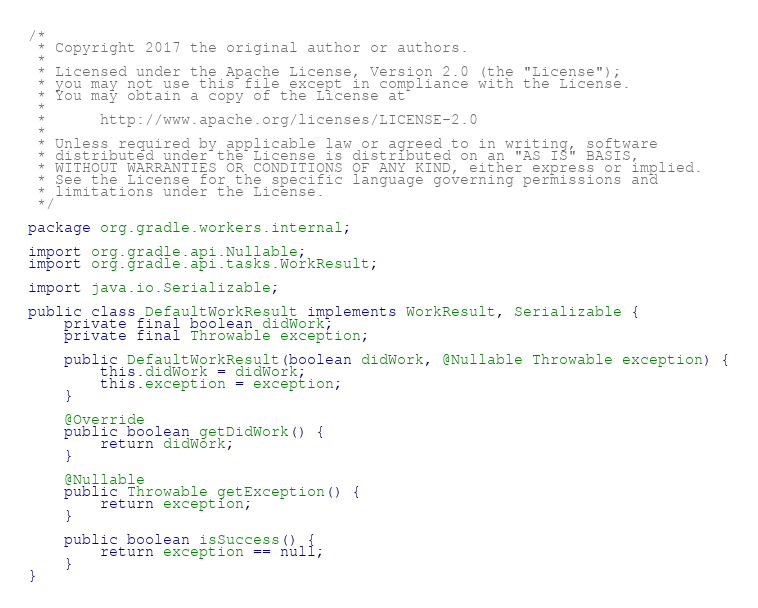<code> <loc_0><loc_0><loc_500><loc_500><_Java_>/*
 * Copyright 2017 the original author or authors.
 *
 * Licensed under the Apache License, Version 2.0 (the "License");
 * you may not use this file except in compliance with the License.
 * You may obtain a copy of the License at
 *
 *      http://www.apache.org/licenses/LICENSE-2.0
 *
 * Unless required by applicable law or agreed to in writing, software
 * distributed under the License is distributed on an "AS IS" BASIS,
 * WITHOUT WARRANTIES OR CONDITIONS OF ANY KIND, either express or implied.
 * See the License for the specific language governing permissions and
 * limitations under the License.
 */

package org.gradle.workers.internal;

import org.gradle.api.Nullable;
import org.gradle.api.tasks.WorkResult;

import java.io.Serializable;

public class DefaultWorkResult implements WorkResult, Serializable {
    private final boolean didWork;
    private final Throwable exception;

    public DefaultWorkResult(boolean didWork, @Nullable Throwable exception) {
        this.didWork = didWork;
        this.exception = exception;
    }

    @Override
    public boolean getDidWork() {
        return didWork;
    }

    @Nullable
    public Throwable getException() {
        return exception;
    }

    public boolean isSuccess() {
        return exception == null;
    }
}
</code> 